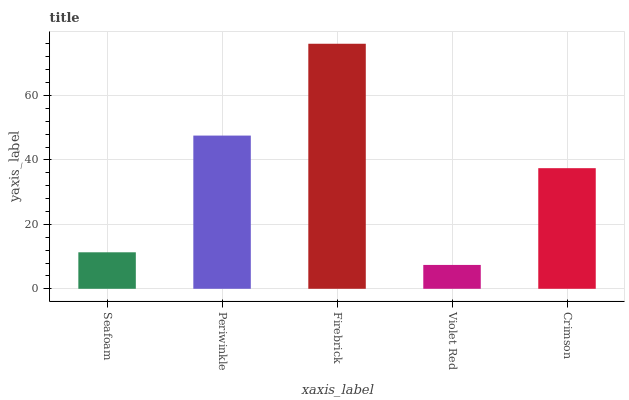Is Violet Red the minimum?
Answer yes or no. Yes. Is Firebrick the maximum?
Answer yes or no. Yes. Is Periwinkle the minimum?
Answer yes or no. No. Is Periwinkle the maximum?
Answer yes or no. No. Is Periwinkle greater than Seafoam?
Answer yes or no. Yes. Is Seafoam less than Periwinkle?
Answer yes or no. Yes. Is Seafoam greater than Periwinkle?
Answer yes or no. No. Is Periwinkle less than Seafoam?
Answer yes or no. No. Is Crimson the high median?
Answer yes or no. Yes. Is Crimson the low median?
Answer yes or no. Yes. Is Firebrick the high median?
Answer yes or no. No. Is Violet Red the low median?
Answer yes or no. No. 